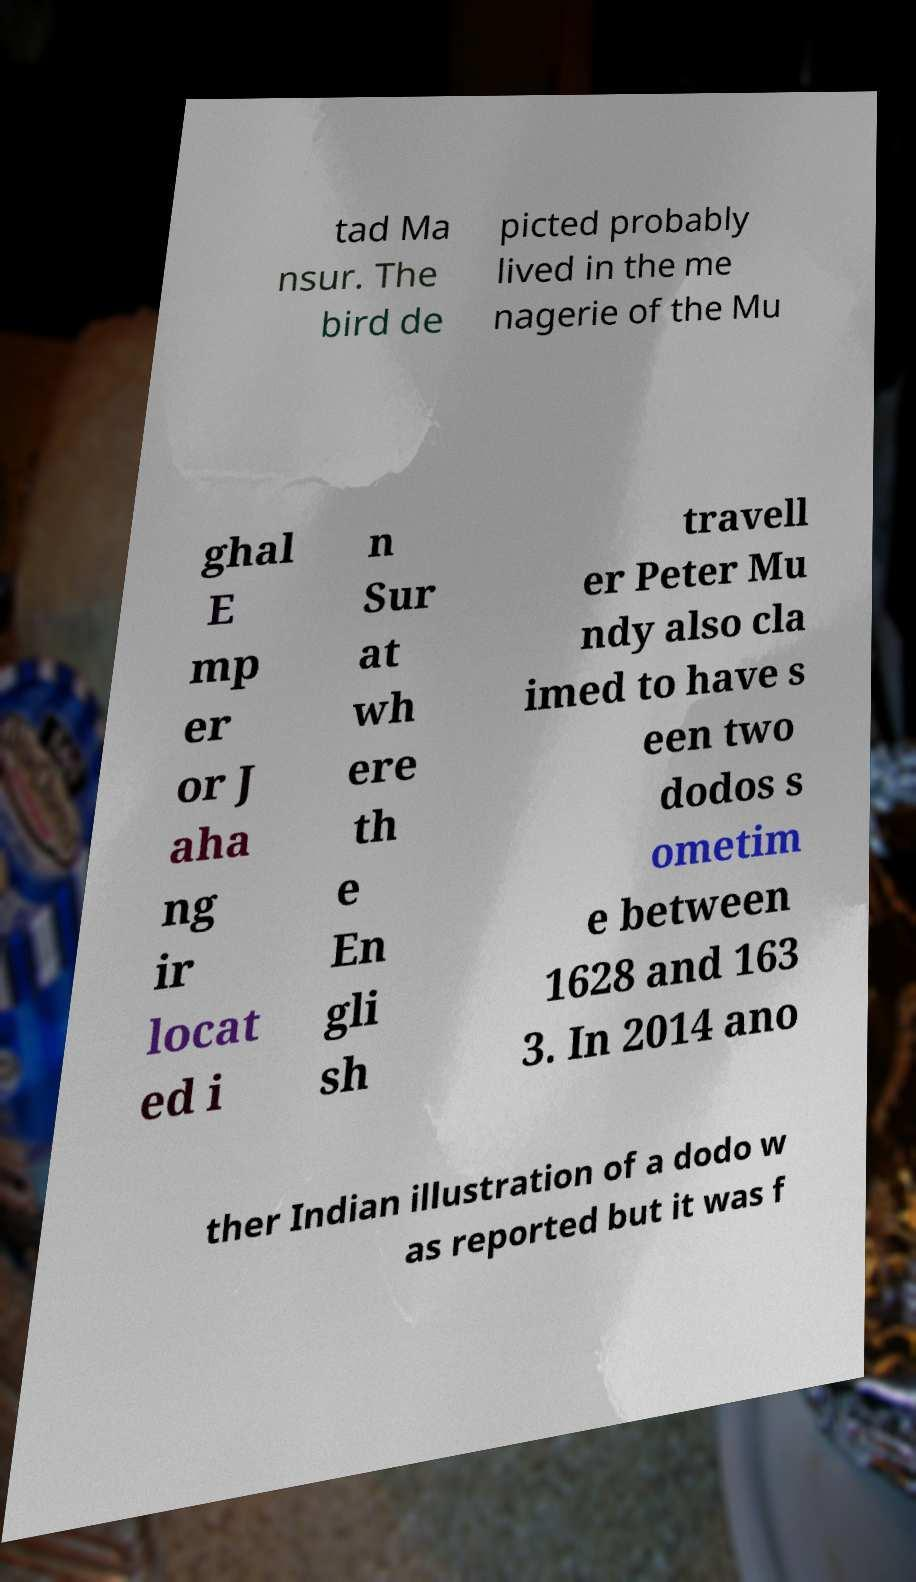Can you read and provide the text displayed in the image?This photo seems to have some interesting text. Can you extract and type it out for me? tad Ma nsur. The bird de picted probably lived in the me nagerie of the Mu ghal E mp er or J aha ng ir locat ed i n Sur at wh ere th e En gli sh travell er Peter Mu ndy also cla imed to have s een two dodos s ometim e between 1628 and 163 3. In 2014 ano ther Indian illustration of a dodo w as reported but it was f 